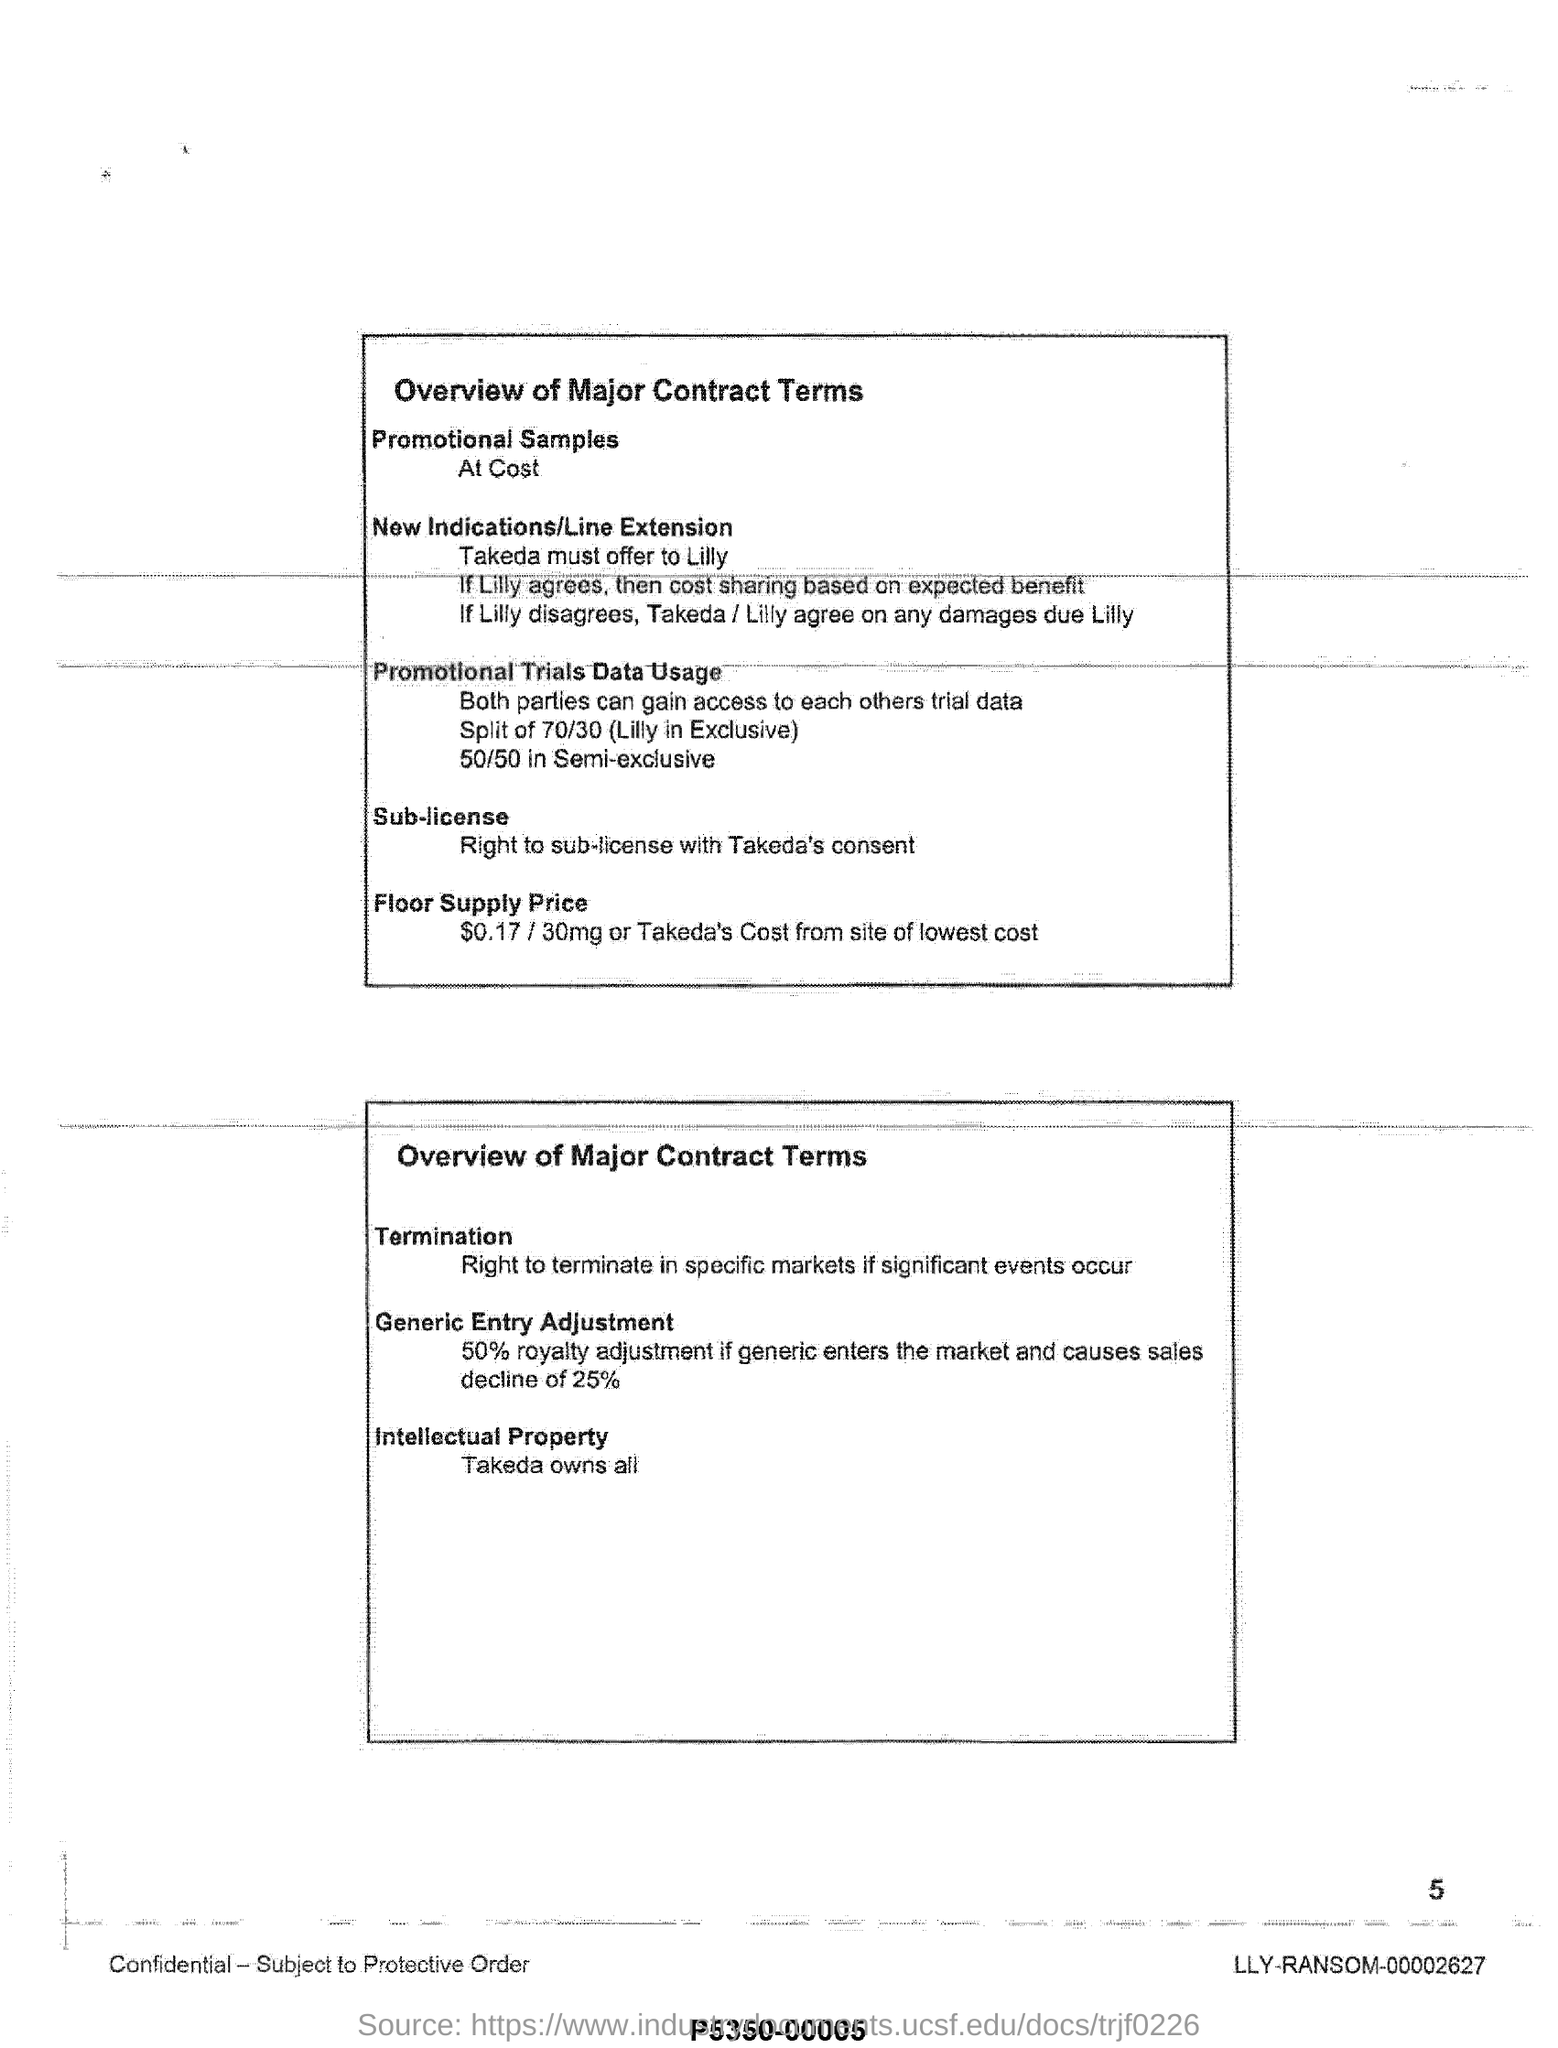Outline some significant characteristics in this image. If a generic drug enters the market, the royalty payment to the licensor may be reduced by 50%. The floor supply price for a 30 mg pack is $0.17, which is the cost that Takeda pays from its lowest cost site. The promotional trial data usage for semi-exclusive is 50/50, meaning that the data usage for both the promotional trial and non-promotional trial will be split equally between the two options. The promotional trial's data usage for Lilly in exclusive is 70/30 split. 